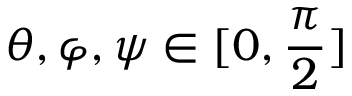Convert formula to latex. <formula><loc_0><loc_0><loc_500><loc_500>\theta , \varphi , \psi \in [ 0 , \frac { \pi } { 2 } ]</formula> 